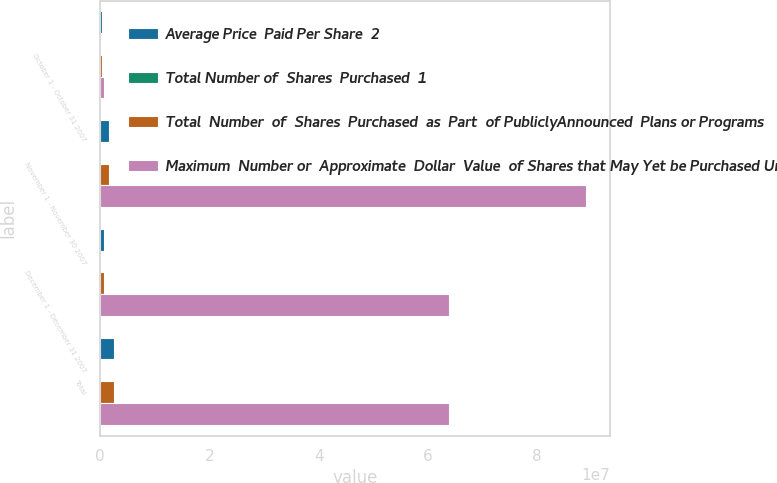Convert chart. <chart><loc_0><loc_0><loc_500><loc_500><stacked_bar_chart><ecel><fcel>October 1 - October 31 2007<fcel>November 1 - November 30 2007<fcel>December 1 - December 31 2007<fcel>Total<nl><fcel>Average Price  Paid Per Share  2<fcel>268100<fcel>1.6526e+06<fcel>686890<fcel>2.60759e+06<nl><fcel>Total Number of  Shares  Purchased  1<fcel>38.01<fcel>37.99<fcel>37.21<fcel>37.79<nl><fcel>Total  Number  of  Shares  Purchased  as  Part  of PubliclyAnnounced  Plans or Programs<fcel>268100<fcel>1.65e+06<fcel>670000<fcel>2.5881e+06<nl><fcel>Maximum  Number or  Approximate  Dollar  Value  of Shares that May Yet be Purchased Under the Plans or Programs  3<fcel>686890<fcel>8.88602e+07<fcel>6.39316e+07<fcel>6.39316e+07<nl></chart> 